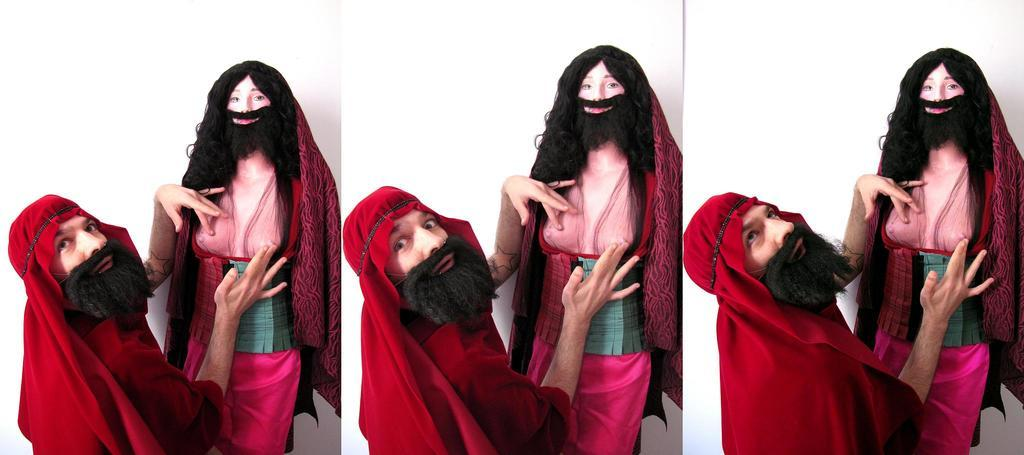What is the main subject of the image? There is a person standing in the image. What is the person doing in the image? The person is touching a statue. What can be observed about the background of the image? The background of the photos in the collage is white. How many bananas are being held by the person in the image? There are no bananas present in the image. What type of twig can be seen in the person's hand in the image? There is no twig present in the person's hand in the image. 